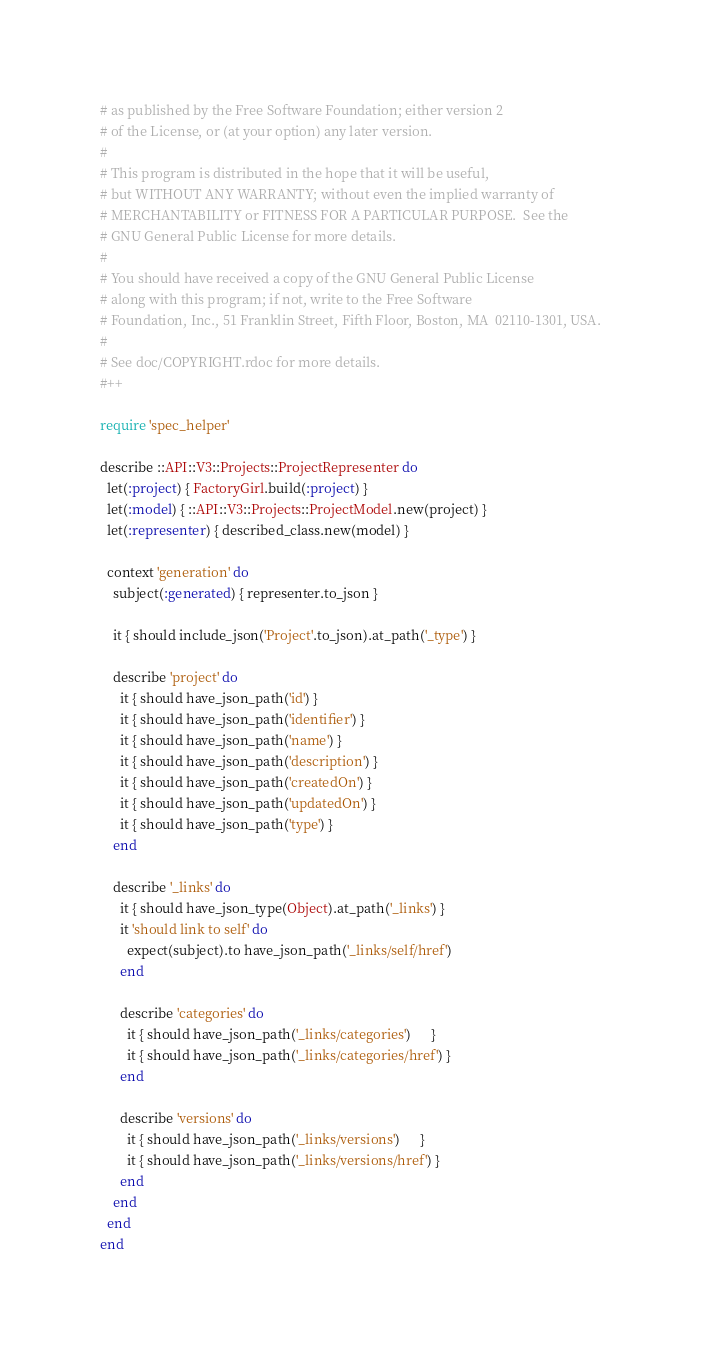Convert code to text. <code><loc_0><loc_0><loc_500><loc_500><_Ruby_># as published by the Free Software Foundation; either version 2
# of the License, or (at your option) any later version.
#
# This program is distributed in the hope that it will be useful,
# but WITHOUT ANY WARRANTY; without even the implied warranty of
# MERCHANTABILITY or FITNESS FOR A PARTICULAR PURPOSE.  See the
# GNU General Public License for more details.
#
# You should have received a copy of the GNU General Public License
# along with this program; if not, write to the Free Software
# Foundation, Inc., 51 Franklin Street, Fifth Floor, Boston, MA  02110-1301, USA.
#
# See doc/COPYRIGHT.rdoc for more details.
#++

require 'spec_helper'

describe ::API::V3::Projects::ProjectRepresenter do
  let(:project) { FactoryGirl.build(:project) }
  let(:model) { ::API::V3::Projects::ProjectModel.new(project) }
  let(:representer) { described_class.new(model) }

  context 'generation' do
    subject(:generated) { representer.to_json }

    it { should include_json('Project'.to_json).at_path('_type') }

    describe 'project' do
      it { should have_json_path('id') }
      it { should have_json_path('identifier') }
      it { should have_json_path('name') }
      it { should have_json_path('description') }
      it { should have_json_path('createdOn') }
      it { should have_json_path('updatedOn') }
      it { should have_json_path('type') }
    end

    describe '_links' do
      it { should have_json_type(Object).at_path('_links') }
      it 'should link to self' do
        expect(subject).to have_json_path('_links/self/href')
      end

      describe 'categories' do
        it { should have_json_path('_links/categories')      }
        it { should have_json_path('_links/categories/href') }
      end

      describe 'versions' do
        it { should have_json_path('_links/versions')      }
        it { should have_json_path('_links/versions/href') }
      end
    end
  end
end
</code> 